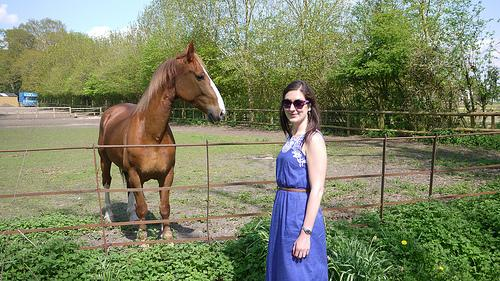Please analyze the emotions or sentiment of the woman in the image. Based on the available data, it is difficult to determine the emotions or sentiment of the woman, as her facial expression is obscured by sunglasses. Count the number of main objects in the image, including the woman, horse, and fence. There are three main objects in the image: the woman, the horse, and the fence. Based on the available information, can you deduce a possible reason or story behind the image? The image may depict a woman visiting a horse in a field or a ranch, observing the animal from behind the fence, possibly enjoying a leisurely day outdoors. Using the provided image data, what are the primary objects in the image? The primary objects in the image are a woman in a purple dress, a brown and white horse, sunglasses on woman's face, and a fence. What is the setting of the image, including the environment and the weather? The image is set in a large field with grass, green bushes beside a metal fence, and trees with green leaves. There is a large white cloud in the sky, indicating a partly cloudy day. What is the distinctive feature of the horse? The horse has a brown head with a white patch on its face and white patches on its back legs. Can you describe the accessories worn by the woman in the image? The woman is wearing sunglasses on her face, a watch on her wrist, and a brown belt around her waist. List any small objects or elements in the environment that add to the overall composition of the image. A yellow flower in the bushes, green leaves on the trees, short green grass in the field, and a rusted fence are small objects that contribute to the overall composition of the image. How is the woman interacting with the horse in the image? The woman is standing close to the horse behind a fence, suggesting she may be interacting or observing the horse. Determine the quality of the image based on the resolution of the objects' image. The image quality appears to be good, as the image for objects have a reasonable size and detail, such as the woman's watch with a width and height of 10 and 19 respectively. 